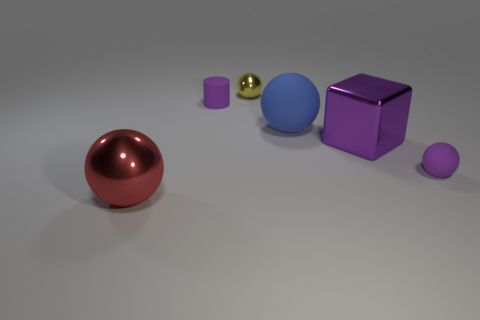Subtract all green balls. Subtract all gray cylinders. How many balls are left? 4 Add 2 yellow metal cylinders. How many objects exist? 8 Subtract all blocks. How many objects are left? 5 Subtract 1 purple spheres. How many objects are left? 5 Subtract all big purple metal cubes. Subtract all matte cylinders. How many objects are left? 4 Add 5 yellow balls. How many yellow balls are left? 6 Add 1 purple cylinders. How many purple cylinders exist? 2 